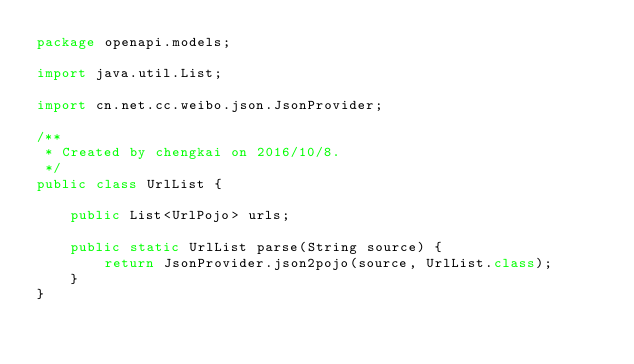<code> <loc_0><loc_0><loc_500><loc_500><_Java_>package openapi.models;

import java.util.List;

import cn.net.cc.weibo.json.JsonProvider;

/**
 * Created by chengkai on 2016/10/8.
 */
public class UrlList {

    public List<UrlPojo> urls;

    public static UrlList parse(String source) {
        return JsonProvider.json2pojo(source, UrlList.class);
    }
}
</code> 